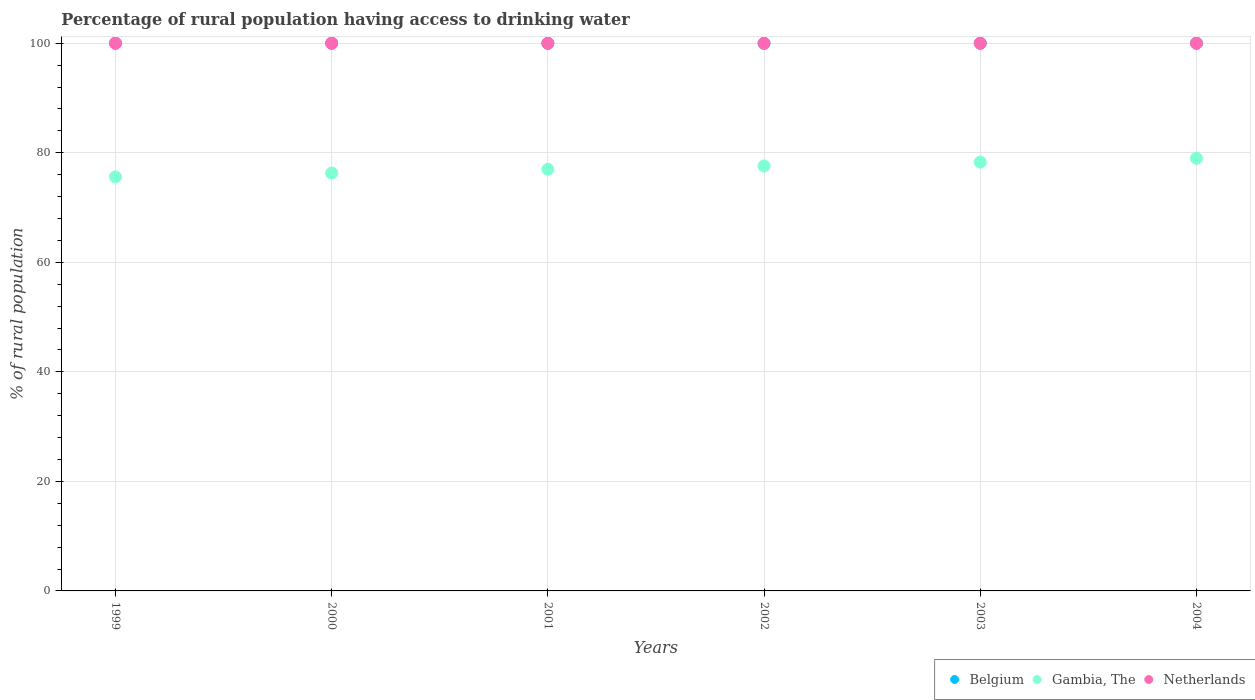What is the percentage of rural population having access to drinking water in Belgium in 2000?
Provide a succinct answer. 100. Across all years, what is the maximum percentage of rural population having access to drinking water in Gambia, The?
Offer a very short reply. 79. Across all years, what is the minimum percentage of rural population having access to drinking water in Belgium?
Your answer should be very brief. 100. In which year was the percentage of rural population having access to drinking water in Belgium minimum?
Offer a very short reply. 1999. What is the total percentage of rural population having access to drinking water in Netherlands in the graph?
Make the answer very short. 600. What is the difference between the percentage of rural population having access to drinking water in Netherlands in 2001 and that in 2002?
Your answer should be very brief. 0. What is the difference between the percentage of rural population having access to drinking water in Belgium in 2003 and the percentage of rural population having access to drinking water in Gambia, The in 1999?
Provide a short and direct response. 24.4. In the year 2004, what is the difference between the percentage of rural population having access to drinking water in Gambia, The and percentage of rural population having access to drinking water in Netherlands?
Provide a short and direct response. -21. In how many years, is the percentage of rural population having access to drinking water in Belgium greater than the average percentage of rural population having access to drinking water in Belgium taken over all years?
Your answer should be very brief. 0. Is the percentage of rural population having access to drinking water in Belgium strictly greater than the percentage of rural population having access to drinking water in Netherlands over the years?
Offer a very short reply. No. How many dotlines are there?
Offer a very short reply. 3. What is the difference between two consecutive major ticks on the Y-axis?
Provide a short and direct response. 20. Are the values on the major ticks of Y-axis written in scientific E-notation?
Your answer should be compact. No. Where does the legend appear in the graph?
Give a very brief answer. Bottom right. How are the legend labels stacked?
Your response must be concise. Horizontal. What is the title of the graph?
Keep it short and to the point. Percentage of rural population having access to drinking water. Does "Gambia, The" appear as one of the legend labels in the graph?
Make the answer very short. Yes. What is the label or title of the X-axis?
Offer a very short reply. Years. What is the label or title of the Y-axis?
Ensure brevity in your answer.  % of rural population. What is the % of rural population in Belgium in 1999?
Give a very brief answer. 100. What is the % of rural population in Gambia, The in 1999?
Offer a terse response. 75.6. What is the % of rural population in Gambia, The in 2000?
Your answer should be very brief. 76.3. What is the % of rural population of Belgium in 2001?
Offer a terse response. 100. What is the % of rural population in Netherlands in 2001?
Your response must be concise. 100. What is the % of rural population of Gambia, The in 2002?
Provide a succinct answer. 77.6. What is the % of rural population in Netherlands in 2002?
Provide a succinct answer. 100. What is the % of rural population of Belgium in 2003?
Keep it short and to the point. 100. What is the % of rural population of Gambia, The in 2003?
Provide a succinct answer. 78.3. What is the % of rural population in Belgium in 2004?
Ensure brevity in your answer.  100. What is the % of rural population of Gambia, The in 2004?
Your response must be concise. 79. What is the % of rural population of Netherlands in 2004?
Ensure brevity in your answer.  100. Across all years, what is the maximum % of rural population of Belgium?
Provide a short and direct response. 100. Across all years, what is the maximum % of rural population of Gambia, The?
Make the answer very short. 79. Across all years, what is the maximum % of rural population in Netherlands?
Ensure brevity in your answer.  100. Across all years, what is the minimum % of rural population in Gambia, The?
Give a very brief answer. 75.6. What is the total % of rural population in Belgium in the graph?
Offer a terse response. 600. What is the total % of rural population of Gambia, The in the graph?
Provide a succinct answer. 463.8. What is the total % of rural population in Netherlands in the graph?
Your answer should be compact. 600. What is the difference between the % of rural population in Belgium in 1999 and that in 2002?
Offer a very short reply. 0. What is the difference between the % of rural population of Belgium in 1999 and that in 2003?
Give a very brief answer. 0. What is the difference between the % of rural population of Gambia, The in 1999 and that in 2003?
Provide a succinct answer. -2.7. What is the difference between the % of rural population in Belgium in 1999 and that in 2004?
Offer a terse response. 0. What is the difference between the % of rural population in Netherlands in 1999 and that in 2004?
Make the answer very short. 0. What is the difference between the % of rural population of Gambia, The in 2000 and that in 2001?
Give a very brief answer. -0.7. What is the difference between the % of rural population in Netherlands in 2000 and that in 2001?
Give a very brief answer. 0. What is the difference between the % of rural population in Netherlands in 2000 and that in 2002?
Provide a succinct answer. 0. What is the difference between the % of rural population in Belgium in 2000 and that in 2003?
Provide a succinct answer. 0. What is the difference between the % of rural population of Gambia, The in 2000 and that in 2003?
Offer a very short reply. -2. What is the difference between the % of rural population in Belgium in 2000 and that in 2004?
Your answer should be very brief. 0. What is the difference between the % of rural population in Gambia, The in 2000 and that in 2004?
Provide a succinct answer. -2.7. What is the difference between the % of rural population of Netherlands in 2000 and that in 2004?
Keep it short and to the point. 0. What is the difference between the % of rural population of Netherlands in 2001 and that in 2002?
Your answer should be very brief. 0. What is the difference between the % of rural population of Belgium in 2001 and that in 2003?
Provide a succinct answer. 0. What is the difference between the % of rural population of Gambia, The in 2001 and that in 2003?
Your response must be concise. -1.3. What is the difference between the % of rural population in Belgium in 2001 and that in 2004?
Ensure brevity in your answer.  0. What is the difference between the % of rural population in Netherlands in 2002 and that in 2003?
Make the answer very short. 0. What is the difference between the % of rural population in Belgium in 2002 and that in 2004?
Your answer should be very brief. 0. What is the difference between the % of rural population in Netherlands in 2002 and that in 2004?
Your response must be concise. 0. What is the difference between the % of rural population in Netherlands in 2003 and that in 2004?
Your answer should be very brief. 0. What is the difference between the % of rural population of Belgium in 1999 and the % of rural population of Gambia, The in 2000?
Make the answer very short. 23.7. What is the difference between the % of rural population of Belgium in 1999 and the % of rural population of Netherlands in 2000?
Provide a short and direct response. 0. What is the difference between the % of rural population in Gambia, The in 1999 and the % of rural population in Netherlands in 2000?
Offer a terse response. -24.4. What is the difference between the % of rural population of Gambia, The in 1999 and the % of rural population of Netherlands in 2001?
Offer a very short reply. -24.4. What is the difference between the % of rural population of Belgium in 1999 and the % of rural population of Gambia, The in 2002?
Offer a very short reply. 22.4. What is the difference between the % of rural population in Gambia, The in 1999 and the % of rural population in Netherlands in 2002?
Provide a short and direct response. -24.4. What is the difference between the % of rural population of Belgium in 1999 and the % of rural population of Gambia, The in 2003?
Provide a short and direct response. 21.7. What is the difference between the % of rural population of Belgium in 1999 and the % of rural population of Netherlands in 2003?
Your answer should be compact. 0. What is the difference between the % of rural population of Gambia, The in 1999 and the % of rural population of Netherlands in 2003?
Ensure brevity in your answer.  -24.4. What is the difference between the % of rural population in Gambia, The in 1999 and the % of rural population in Netherlands in 2004?
Make the answer very short. -24.4. What is the difference between the % of rural population in Gambia, The in 2000 and the % of rural population in Netherlands in 2001?
Make the answer very short. -23.7. What is the difference between the % of rural population in Belgium in 2000 and the % of rural population in Gambia, The in 2002?
Keep it short and to the point. 22.4. What is the difference between the % of rural population of Belgium in 2000 and the % of rural population of Netherlands in 2002?
Offer a very short reply. 0. What is the difference between the % of rural population of Gambia, The in 2000 and the % of rural population of Netherlands in 2002?
Offer a terse response. -23.7. What is the difference between the % of rural population in Belgium in 2000 and the % of rural population in Gambia, The in 2003?
Your answer should be compact. 21.7. What is the difference between the % of rural population of Gambia, The in 2000 and the % of rural population of Netherlands in 2003?
Your answer should be compact. -23.7. What is the difference between the % of rural population of Belgium in 2000 and the % of rural population of Netherlands in 2004?
Keep it short and to the point. 0. What is the difference between the % of rural population of Gambia, The in 2000 and the % of rural population of Netherlands in 2004?
Your response must be concise. -23.7. What is the difference between the % of rural population of Belgium in 2001 and the % of rural population of Gambia, The in 2002?
Offer a very short reply. 22.4. What is the difference between the % of rural population of Belgium in 2001 and the % of rural population of Netherlands in 2002?
Keep it short and to the point. 0. What is the difference between the % of rural population in Belgium in 2001 and the % of rural population in Gambia, The in 2003?
Give a very brief answer. 21.7. What is the difference between the % of rural population of Gambia, The in 2001 and the % of rural population of Netherlands in 2003?
Keep it short and to the point. -23. What is the difference between the % of rural population in Belgium in 2002 and the % of rural population in Gambia, The in 2003?
Your response must be concise. 21.7. What is the difference between the % of rural population in Belgium in 2002 and the % of rural population in Netherlands in 2003?
Offer a terse response. 0. What is the difference between the % of rural population in Gambia, The in 2002 and the % of rural population in Netherlands in 2003?
Your response must be concise. -22.4. What is the difference between the % of rural population of Belgium in 2002 and the % of rural population of Gambia, The in 2004?
Make the answer very short. 21. What is the difference between the % of rural population of Belgium in 2002 and the % of rural population of Netherlands in 2004?
Provide a succinct answer. 0. What is the difference between the % of rural population in Gambia, The in 2002 and the % of rural population in Netherlands in 2004?
Give a very brief answer. -22.4. What is the difference between the % of rural population of Gambia, The in 2003 and the % of rural population of Netherlands in 2004?
Offer a terse response. -21.7. What is the average % of rural population in Belgium per year?
Offer a very short reply. 100. What is the average % of rural population in Gambia, The per year?
Make the answer very short. 77.3. What is the average % of rural population in Netherlands per year?
Give a very brief answer. 100. In the year 1999, what is the difference between the % of rural population in Belgium and % of rural population in Gambia, The?
Offer a terse response. 24.4. In the year 1999, what is the difference between the % of rural population in Gambia, The and % of rural population in Netherlands?
Give a very brief answer. -24.4. In the year 2000, what is the difference between the % of rural population in Belgium and % of rural population in Gambia, The?
Your response must be concise. 23.7. In the year 2000, what is the difference between the % of rural population in Belgium and % of rural population in Netherlands?
Your answer should be very brief. 0. In the year 2000, what is the difference between the % of rural population in Gambia, The and % of rural population in Netherlands?
Provide a succinct answer. -23.7. In the year 2001, what is the difference between the % of rural population in Belgium and % of rural population in Gambia, The?
Make the answer very short. 23. In the year 2001, what is the difference between the % of rural population in Belgium and % of rural population in Netherlands?
Provide a succinct answer. 0. In the year 2002, what is the difference between the % of rural population of Belgium and % of rural population of Gambia, The?
Your answer should be very brief. 22.4. In the year 2002, what is the difference between the % of rural population of Gambia, The and % of rural population of Netherlands?
Provide a succinct answer. -22.4. In the year 2003, what is the difference between the % of rural population in Belgium and % of rural population in Gambia, The?
Offer a very short reply. 21.7. In the year 2003, what is the difference between the % of rural population in Gambia, The and % of rural population in Netherlands?
Your response must be concise. -21.7. In the year 2004, what is the difference between the % of rural population in Belgium and % of rural population in Netherlands?
Provide a succinct answer. 0. In the year 2004, what is the difference between the % of rural population in Gambia, The and % of rural population in Netherlands?
Offer a terse response. -21. What is the ratio of the % of rural population of Belgium in 1999 to that in 2000?
Your response must be concise. 1. What is the ratio of the % of rural population in Netherlands in 1999 to that in 2000?
Your answer should be very brief. 1. What is the ratio of the % of rural population in Belgium in 1999 to that in 2001?
Offer a terse response. 1. What is the ratio of the % of rural population of Gambia, The in 1999 to that in 2001?
Provide a short and direct response. 0.98. What is the ratio of the % of rural population in Belgium in 1999 to that in 2002?
Offer a terse response. 1. What is the ratio of the % of rural population of Gambia, The in 1999 to that in 2002?
Offer a very short reply. 0.97. What is the ratio of the % of rural population in Netherlands in 1999 to that in 2002?
Your answer should be very brief. 1. What is the ratio of the % of rural population of Belgium in 1999 to that in 2003?
Give a very brief answer. 1. What is the ratio of the % of rural population of Gambia, The in 1999 to that in 2003?
Your response must be concise. 0.97. What is the ratio of the % of rural population of Belgium in 1999 to that in 2004?
Your answer should be very brief. 1. What is the ratio of the % of rural population of Gambia, The in 1999 to that in 2004?
Your answer should be compact. 0.96. What is the ratio of the % of rural population in Netherlands in 1999 to that in 2004?
Make the answer very short. 1. What is the ratio of the % of rural population in Gambia, The in 2000 to that in 2001?
Give a very brief answer. 0.99. What is the ratio of the % of rural population of Belgium in 2000 to that in 2002?
Offer a terse response. 1. What is the ratio of the % of rural population of Gambia, The in 2000 to that in 2002?
Make the answer very short. 0.98. What is the ratio of the % of rural population of Gambia, The in 2000 to that in 2003?
Keep it short and to the point. 0.97. What is the ratio of the % of rural population in Gambia, The in 2000 to that in 2004?
Make the answer very short. 0.97. What is the ratio of the % of rural population in Gambia, The in 2001 to that in 2003?
Keep it short and to the point. 0.98. What is the ratio of the % of rural population of Netherlands in 2001 to that in 2003?
Your answer should be very brief. 1. What is the ratio of the % of rural population of Belgium in 2001 to that in 2004?
Give a very brief answer. 1. What is the ratio of the % of rural population in Gambia, The in 2001 to that in 2004?
Provide a succinct answer. 0.97. What is the ratio of the % of rural population in Netherlands in 2001 to that in 2004?
Offer a very short reply. 1. What is the ratio of the % of rural population in Belgium in 2002 to that in 2003?
Keep it short and to the point. 1. What is the ratio of the % of rural population in Gambia, The in 2002 to that in 2003?
Ensure brevity in your answer.  0.99. What is the ratio of the % of rural population of Netherlands in 2002 to that in 2003?
Your answer should be very brief. 1. What is the ratio of the % of rural population in Belgium in 2002 to that in 2004?
Offer a very short reply. 1. What is the ratio of the % of rural population in Gambia, The in 2002 to that in 2004?
Your answer should be very brief. 0.98. What is the ratio of the % of rural population in Gambia, The in 2003 to that in 2004?
Offer a very short reply. 0.99. What is the ratio of the % of rural population in Netherlands in 2003 to that in 2004?
Give a very brief answer. 1. What is the difference between the highest and the second highest % of rural population of Gambia, The?
Offer a terse response. 0.7. What is the difference between the highest and the second highest % of rural population of Netherlands?
Your answer should be very brief. 0. What is the difference between the highest and the lowest % of rural population of Belgium?
Your answer should be very brief. 0. What is the difference between the highest and the lowest % of rural population of Netherlands?
Ensure brevity in your answer.  0. 